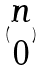<formula> <loc_0><loc_0><loc_500><loc_500>( \begin{matrix} n \\ 0 \end{matrix} )</formula> 